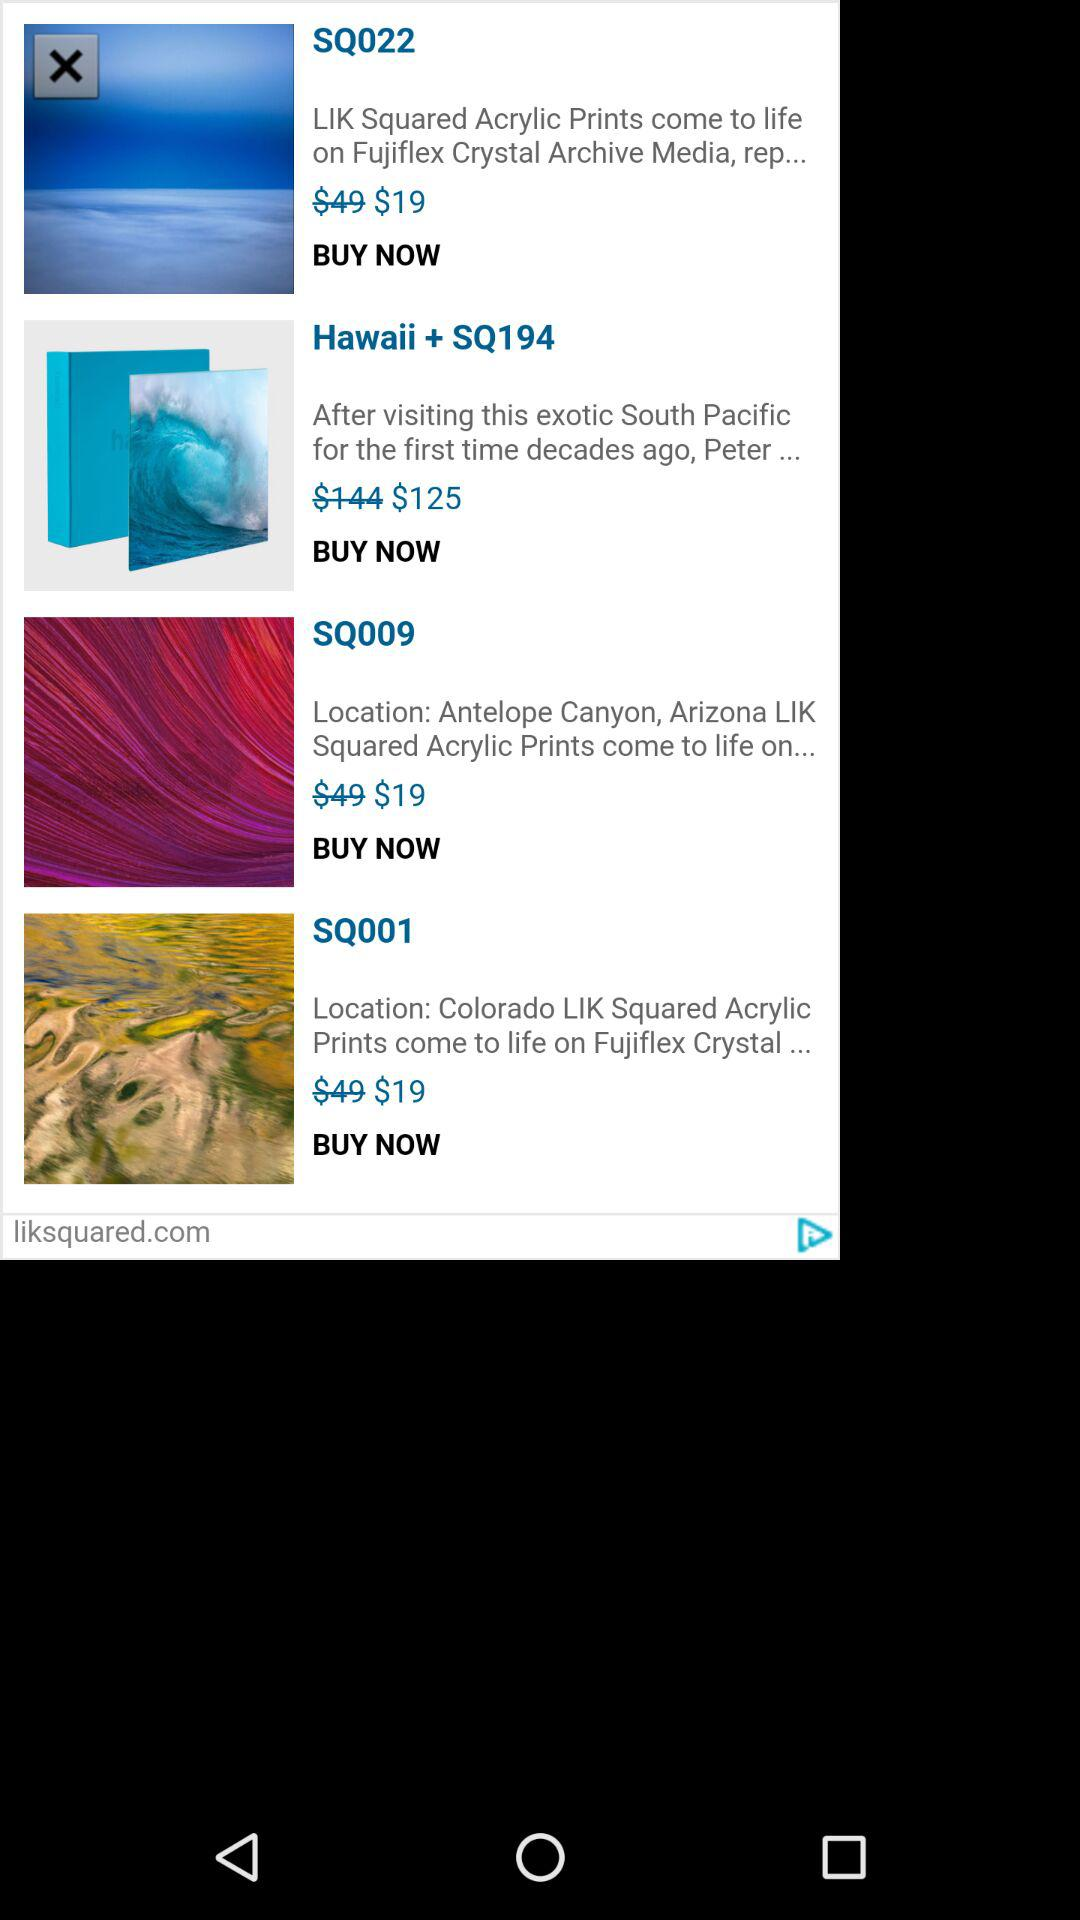What is the price of the SQ022? The price of the SQ022 is $19. 